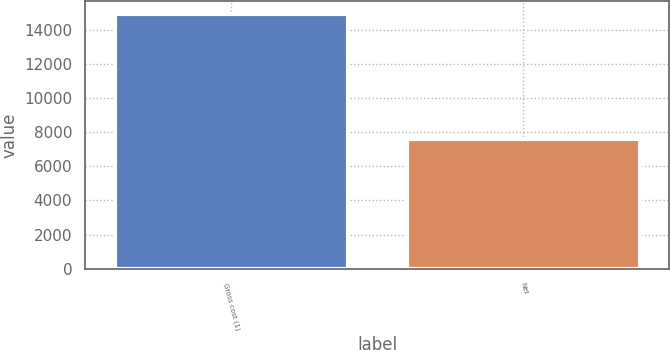<chart> <loc_0><loc_0><loc_500><loc_500><bar_chart><fcel>Gross cost (1)<fcel>Net<nl><fcel>14910<fcel>7595<nl></chart> 